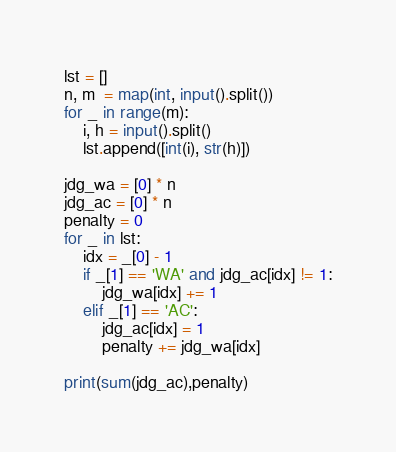Convert code to text. <code><loc_0><loc_0><loc_500><loc_500><_Python_>lst = []
n, m  = map(int, input().split())
for _ in range(m):
    i, h = input().split()
    lst.append([int(i), str(h)])

jdg_wa = [0] * n 
jdg_ac = [0] * n
penalty = 0
for _ in lst:
    idx = _[0] - 1
    if _[1] == 'WA' and jdg_ac[idx] != 1:
        jdg_wa[idx] += 1
    elif _[1] == 'AC':
        jdg_ac[idx] = 1
        penalty += jdg_wa[idx]
        
print(sum(jdg_ac),penalty)
</code> 